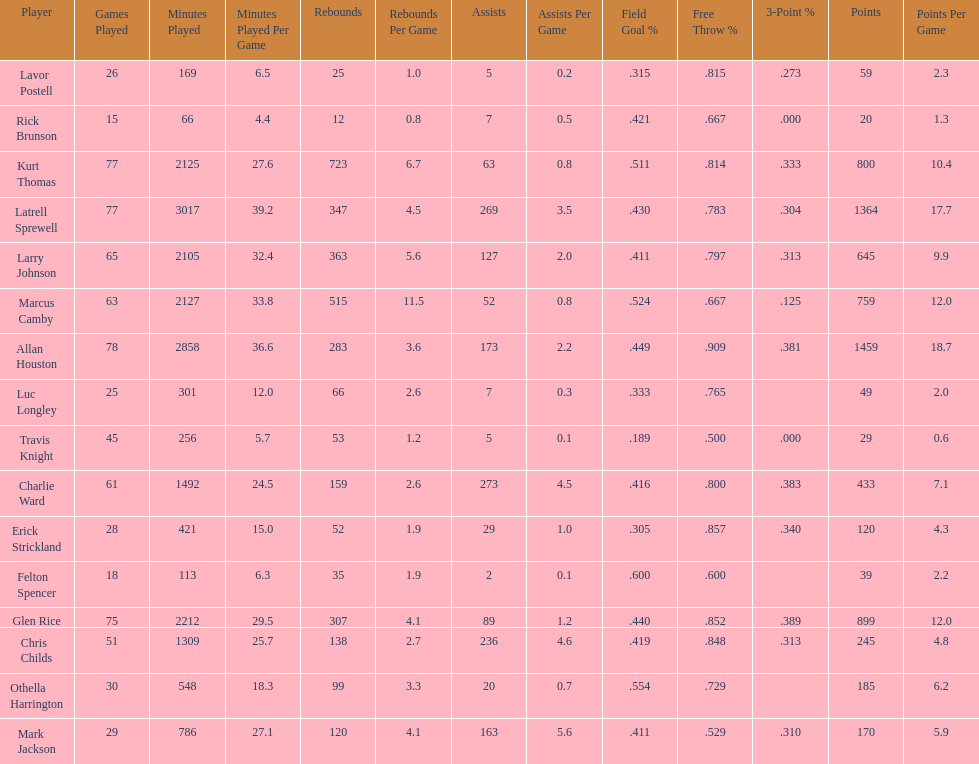How many more games did allan houston play than mark jackson? 49. Parse the full table. {'header': ['Player', 'Games Played', 'Minutes Played', 'Minutes Played Per Game', 'Rebounds', 'Rebounds Per Game', 'Assists', 'Assists Per Game', 'Field Goal\xa0%', 'Free Throw\xa0%', '3-Point\xa0%', 'Points', 'Points Per Game'], 'rows': [['Lavor Postell', '26', '169', '6.5', '25', '1.0', '5', '0.2', '.315', '.815', '.273', '59', '2.3'], ['Rick Brunson', '15', '66', '4.4', '12', '0.8', '7', '0.5', '.421', '.667', '.000', '20', '1.3'], ['Kurt Thomas', '77', '2125', '27.6', '723', '6.7', '63', '0.8', '.511', '.814', '.333', '800', '10.4'], ['Latrell Sprewell', '77', '3017', '39.2', '347', '4.5', '269', '3.5', '.430', '.783', '.304', '1364', '17.7'], ['Larry Johnson', '65', '2105', '32.4', '363', '5.6', '127', '2.0', '.411', '.797', '.313', '645', '9.9'], ['Marcus Camby', '63', '2127', '33.8', '515', '11.5', '52', '0.8', '.524', '.667', '.125', '759', '12.0'], ['Allan Houston', '78', '2858', '36.6', '283', '3.6', '173', '2.2', '.449', '.909', '.381', '1459', '18.7'], ['Luc Longley', '25', '301', '12.0', '66', '2.6', '7', '0.3', '.333', '.765', '', '49', '2.0'], ['Travis Knight', '45', '256', '5.7', '53', '1.2', '5', '0.1', '.189', '.500', '.000', '29', '0.6'], ['Charlie Ward', '61', '1492', '24.5', '159', '2.6', '273', '4.5', '.416', '.800', '.383', '433', '7.1'], ['Erick Strickland', '28', '421', '15.0', '52', '1.9', '29', '1.0', '.305', '.857', '.340', '120', '4.3'], ['Felton Spencer', '18', '113', '6.3', '35', '1.9', '2', '0.1', '.600', '.600', '', '39', '2.2'], ['Glen Rice', '75', '2212', '29.5', '307', '4.1', '89', '1.2', '.440', '.852', '.389', '899', '12.0'], ['Chris Childs', '51', '1309', '25.7', '138', '2.7', '236', '4.6', '.419', '.848', '.313', '245', '4.8'], ['Othella Harrington', '30', '548', '18.3', '99', '3.3', '20', '0.7', '.554', '.729', '', '185', '6.2'], ['Mark Jackson', '29', '786', '27.1', '120', '4.1', '163', '5.6', '.411', '.529', '.310', '170', '5.9']]} 